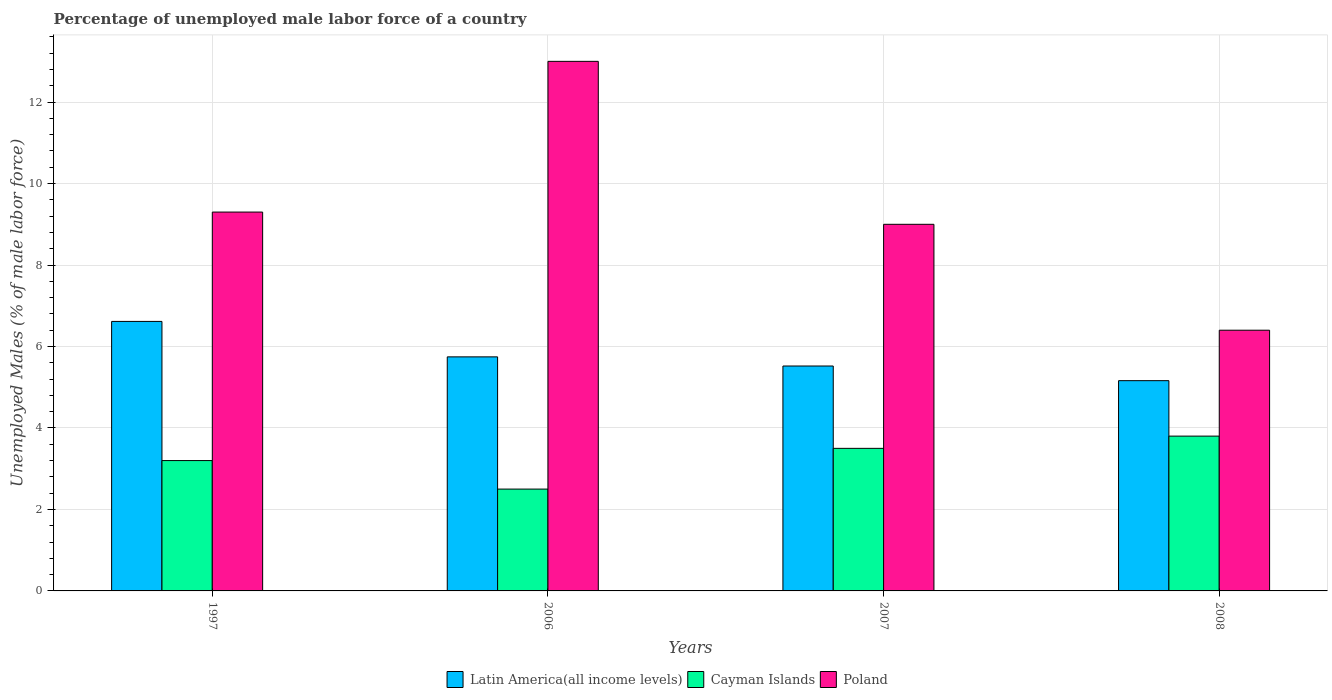How many groups of bars are there?
Your response must be concise. 4. Are the number of bars per tick equal to the number of legend labels?
Provide a short and direct response. Yes. What is the label of the 3rd group of bars from the left?
Your answer should be compact. 2007. What is the percentage of unemployed male labor force in Poland in 2007?
Make the answer very short. 9. Across all years, what is the maximum percentage of unemployed male labor force in Latin America(all income levels)?
Your response must be concise. 6.62. Across all years, what is the minimum percentage of unemployed male labor force in Latin America(all income levels)?
Your answer should be very brief. 5.16. What is the total percentage of unemployed male labor force in Latin America(all income levels) in the graph?
Provide a succinct answer. 23.04. What is the difference between the percentage of unemployed male labor force in Latin America(all income levels) in 2006 and that in 2007?
Keep it short and to the point. 0.22. What is the average percentage of unemployed male labor force in Latin America(all income levels) per year?
Give a very brief answer. 5.76. In the year 2006, what is the difference between the percentage of unemployed male labor force in Latin America(all income levels) and percentage of unemployed male labor force in Cayman Islands?
Keep it short and to the point. 3.25. In how many years, is the percentage of unemployed male labor force in Latin America(all income levels) greater than 2.4 %?
Make the answer very short. 4. What is the ratio of the percentage of unemployed male labor force in Poland in 2007 to that in 2008?
Make the answer very short. 1.41. What is the difference between the highest and the second highest percentage of unemployed male labor force in Latin America(all income levels)?
Ensure brevity in your answer.  0.87. What is the difference between the highest and the lowest percentage of unemployed male labor force in Poland?
Offer a very short reply. 6.6. What does the 3rd bar from the right in 1997 represents?
Your response must be concise. Latin America(all income levels). Is it the case that in every year, the sum of the percentage of unemployed male labor force in Poland and percentage of unemployed male labor force in Latin America(all income levels) is greater than the percentage of unemployed male labor force in Cayman Islands?
Ensure brevity in your answer.  Yes. Are all the bars in the graph horizontal?
Give a very brief answer. No. What is the difference between two consecutive major ticks on the Y-axis?
Your answer should be very brief. 2. Are the values on the major ticks of Y-axis written in scientific E-notation?
Your answer should be compact. No. Does the graph contain any zero values?
Your answer should be compact. No. How many legend labels are there?
Your answer should be compact. 3. What is the title of the graph?
Provide a short and direct response. Percentage of unemployed male labor force of a country. Does "Honduras" appear as one of the legend labels in the graph?
Provide a succinct answer. No. What is the label or title of the Y-axis?
Your answer should be compact. Unemployed Males (% of male labor force). What is the Unemployed Males (% of male labor force) in Latin America(all income levels) in 1997?
Keep it short and to the point. 6.62. What is the Unemployed Males (% of male labor force) of Cayman Islands in 1997?
Your answer should be very brief. 3.2. What is the Unemployed Males (% of male labor force) of Poland in 1997?
Your answer should be compact. 9.3. What is the Unemployed Males (% of male labor force) of Latin America(all income levels) in 2006?
Provide a succinct answer. 5.75. What is the Unemployed Males (% of male labor force) in Cayman Islands in 2006?
Keep it short and to the point. 2.5. What is the Unemployed Males (% of male labor force) in Latin America(all income levels) in 2007?
Provide a short and direct response. 5.52. What is the Unemployed Males (% of male labor force) in Cayman Islands in 2007?
Make the answer very short. 3.5. What is the Unemployed Males (% of male labor force) of Latin America(all income levels) in 2008?
Give a very brief answer. 5.16. What is the Unemployed Males (% of male labor force) of Cayman Islands in 2008?
Keep it short and to the point. 3.8. What is the Unemployed Males (% of male labor force) in Poland in 2008?
Provide a short and direct response. 6.4. Across all years, what is the maximum Unemployed Males (% of male labor force) in Latin America(all income levels)?
Your response must be concise. 6.62. Across all years, what is the maximum Unemployed Males (% of male labor force) of Cayman Islands?
Your answer should be compact. 3.8. Across all years, what is the maximum Unemployed Males (% of male labor force) of Poland?
Offer a very short reply. 13. Across all years, what is the minimum Unemployed Males (% of male labor force) in Latin America(all income levels)?
Ensure brevity in your answer.  5.16. Across all years, what is the minimum Unemployed Males (% of male labor force) in Poland?
Your answer should be compact. 6.4. What is the total Unemployed Males (% of male labor force) of Latin America(all income levels) in the graph?
Keep it short and to the point. 23.04. What is the total Unemployed Males (% of male labor force) of Cayman Islands in the graph?
Offer a very short reply. 13. What is the total Unemployed Males (% of male labor force) in Poland in the graph?
Offer a very short reply. 37.7. What is the difference between the Unemployed Males (% of male labor force) of Latin America(all income levels) in 1997 and that in 2006?
Offer a very short reply. 0.87. What is the difference between the Unemployed Males (% of male labor force) of Cayman Islands in 1997 and that in 2006?
Make the answer very short. 0.7. What is the difference between the Unemployed Males (% of male labor force) in Poland in 1997 and that in 2006?
Keep it short and to the point. -3.7. What is the difference between the Unemployed Males (% of male labor force) of Latin America(all income levels) in 1997 and that in 2007?
Your response must be concise. 1.09. What is the difference between the Unemployed Males (% of male labor force) of Latin America(all income levels) in 1997 and that in 2008?
Make the answer very short. 1.45. What is the difference between the Unemployed Males (% of male labor force) of Cayman Islands in 1997 and that in 2008?
Keep it short and to the point. -0.6. What is the difference between the Unemployed Males (% of male labor force) of Poland in 1997 and that in 2008?
Your response must be concise. 2.9. What is the difference between the Unemployed Males (% of male labor force) in Latin America(all income levels) in 2006 and that in 2007?
Ensure brevity in your answer.  0.22. What is the difference between the Unemployed Males (% of male labor force) in Cayman Islands in 2006 and that in 2007?
Provide a succinct answer. -1. What is the difference between the Unemployed Males (% of male labor force) in Poland in 2006 and that in 2007?
Offer a very short reply. 4. What is the difference between the Unemployed Males (% of male labor force) of Latin America(all income levels) in 2006 and that in 2008?
Ensure brevity in your answer.  0.58. What is the difference between the Unemployed Males (% of male labor force) of Latin America(all income levels) in 2007 and that in 2008?
Your answer should be very brief. 0.36. What is the difference between the Unemployed Males (% of male labor force) in Latin America(all income levels) in 1997 and the Unemployed Males (% of male labor force) in Cayman Islands in 2006?
Your answer should be compact. 4.12. What is the difference between the Unemployed Males (% of male labor force) of Latin America(all income levels) in 1997 and the Unemployed Males (% of male labor force) of Poland in 2006?
Provide a short and direct response. -6.38. What is the difference between the Unemployed Males (% of male labor force) in Cayman Islands in 1997 and the Unemployed Males (% of male labor force) in Poland in 2006?
Your answer should be compact. -9.8. What is the difference between the Unemployed Males (% of male labor force) in Latin America(all income levels) in 1997 and the Unemployed Males (% of male labor force) in Cayman Islands in 2007?
Your answer should be compact. 3.12. What is the difference between the Unemployed Males (% of male labor force) in Latin America(all income levels) in 1997 and the Unemployed Males (% of male labor force) in Poland in 2007?
Offer a very short reply. -2.38. What is the difference between the Unemployed Males (% of male labor force) of Cayman Islands in 1997 and the Unemployed Males (% of male labor force) of Poland in 2007?
Offer a terse response. -5.8. What is the difference between the Unemployed Males (% of male labor force) of Latin America(all income levels) in 1997 and the Unemployed Males (% of male labor force) of Cayman Islands in 2008?
Offer a very short reply. 2.82. What is the difference between the Unemployed Males (% of male labor force) in Latin America(all income levels) in 1997 and the Unemployed Males (% of male labor force) in Poland in 2008?
Give a very brief answer. 0.22. What is the difference between the Unemployed Males (% of male labor force) of Cayman Islands in 1997 and the Unemployed Males (% of male labor force) of Poland in 2008?
Your answer should be compact. -3.2. What is the difference between the Unemployed Males (% of male labor force) in Latin America(all income levels) in 2006 and the Unemployed Males (% of male labor force) in Cayman Islands in 2007?
Ensure brevity in your answer.  2.25. What is the difference between the Unemployed Males (% of male labor force) in Latin America(all income levels) in 2006 and the Unemployed Males (% of male labor force) in Poland in 2007?
Your answer should be very brief. -3.25. What is the difference between the Unemployed Males (% of male labor force) in Latin America(all income levels) in 2006 and the Unemployed Males (% of male labor force) in Cayman Islands in 2008?
Your response must be concise. 1.95. What is the difference between the Unemployed Males (% of male labor force) in Latin America(all income levels) in 2006 and the Unemployed Males (% of male labor force) in Poland in 2008?
Make the answer very short. -0.65. What is the difference between the Unemployed Males (% of male labor force) in Latin America(all income levels) in 2007 and the Unemployed Males (% of male labor force) in Cayman Islands in 2008?
Keep it short and to the point. 1.72. What is the difference between the Unemployed Males (% of male labor force) of Latin America(all income levels) in 2007 and the Unemployed Males (% of male labor force) of Poland in 2008?
Your answer should be compact. -0.88. What is the difference between the Unemployed Males (% of male labor force) of Cayman Islands in 2007 and the Unemployed Males (% of male labor force) of Poland in 2008?
Keep it short and to the point. -2.9. What is the average Unemployed Males (% of male labor force) of Latin America(all income levels) per year?
Give a very brief answer. 5.76. What is the average Unemployed Males (% of male labor force) in Cayman Islands per year?
Ensure brevity in your answer.  3.25. What is the average Unemployed Males (% of male labor force) in Poland per year?
Keep it short and to the point. 9.43. In the year 1997, what is the difference between the Unemployed Males (% of male labor force) of Latin America(all income levels) and Unemployed Males (% of male labor force) of Cayman Islands?
Ensure brevity in your answer.  3.42. In the year 1997, what is the difference between the Unemployed Males (% of male labor force) of Latin America(all income levels) and Unemployed Males (% of male labor force) of Poland?
Keep it short and to the point. -2.68. In the year 2006, what is the difference between the Unemployed Males (% of male labor force) in Latin America(all income levels) and Unemployed Males (% of male labor force) in Cayman Islands?
Provide a succinct answer. 3.25. In the year 2006, what is the difference between the Unemployed Males (% of male labor force) of Latin America(all income levels) and Unemployed Males (% of male labor force) of Poland?
Keep it short and to the point. -7.25. In the year 2006, what is the difference between the Unemployed Males (% of male labor force) in Cayman Islands and Unemployed Males (% of male labor force) in Poland?
Offer a very short reply. -10.5. In the year 2007, what is the difference between the Unemployed Males (% of male labor force) of Latin America(all income levels) and Unemployed Males (% of male labor force) of Cayman Islands?
Keep it short and to the point. 2.02. In the year 2007, what is the difference between the Unemployed Males (% of male labor force) of Latin America(all income levels) and Unemployed Males (% of male labor force) of Poland?
Provide a succinct answer. -3.48. In the year 2008, what is the difference between the Unemployed Males (% of male labor force) of Latin America(all income levels) and Unemployed Males (% of male labor force) of Cayman Islands?
Your answer should be very brief. 1.36. In the year 2008, what is the difference between the Unemployed Males (% of male labor force) of Latin America(all income levels) and Unemployed Males (% of male labor force) of Poland?
Give a very brief answer. -1.24. In the year 2008, what is the difference between the Unemployed Males (% of male labor force) of Cayman Islands and Unemployed Males (% of male labor force) of Poland?
Offer a very short reply. -2.6. What is the ratio of the Unemployed Males (% of male labor force) in Latin America(all income levels) in 1997 to that in 2006?
Make the answer very short. 1.15. What is the ratio of the Unemployed Males (% of male labor force) in Cayman Islands in 1997 to that in 2006?
Offer a very short reply. 1.28. What is the ratio of the Unemployed Males (% of male labor force) in Poland in 1997 to that in 2006?
Your response must be concise. 0.72. What is the ratio of the Unemployed Males (% of male labor force) in Latin America(all income levels) in 1997 to that in 2007?
Your response must be concise. 1.2. What is the ratio of the Unemployed Males (% of male labor force) in Cayman Islands in 1997 to that in 2007?
Give a very brief answer. 0.91. What is the ratio of the Unemployed Males (% of male labor force) of Poland in 1997 to that in 2007?
Make the answer very short. 1.03. What is the ratio of the Unemployed Males (% of male labor force) of Latin America(all income levels) in 1997 to that in 2008?
Provide a short and direct response. 1.28. What is the ratio of the Unemployed Males (% of male labor force) of Cayman Islands in 1997 to that in 2008?
Provide a short and direct response. 0.84. What is the ratio of the Unemployed Males (% of male labor force) of Poland in 1997 to that in 2008?
Your response must be concise. 1.45. What is the ratio of the Unemployed Males (% of male labor force) in Latin America(all income levels) in 2006 to that in 2007?
Your answer should be very brief. 1.04. What is the ratio of the Unemployed Males (% of male labor force) of Poland in 2006 to that in 2007?
Keep it short and to the point. 1.44. What is the ratio of the Unemployed Males (% of male labor force) in Latin America(all income levels) in 2006 to that in 2008?
Offer a terse response. 1.11. What is the ratio of the Unemployed Males (% of male labor force) in Cayman Islands in 2006 to that in 2008?
Ensure brevity in your answer.  0.66. What is the ratio of the Unemployed Males (% of male labor force) in Poland in 2006 to that in 2008?
Provide a short and direct response. 2.03. What is the ratio of the Unemployed Males (% of male labor force) of Latin America(all income levels) in 2007 to that in 2008?
Ensure brevity in your answer.  1.07. What is the ratio of the Unemployed Males (% of male labor force) in Cayman Islands in 2007 to that in 2008?
Keep it short and to the point. 0.92. What is the ratio of the Unemployed Males (% of male labor force) in Poland in 2007 to that in 2008?
Ensure brevity in your answer.  1.41. What is the difference between the highest and the second highest Unemployed Males (% of male labor force) of Latin America(all income levels)?
Your answer should be very brief. 0.87. What is the difference between the highest and the second highest Unemployed Males (% of male labor force) of Cayman Islands?
Provide a succinct answer. 0.3. What is the difference between the highest and the lowest Unemployed Males (% of male labor force) of Latin America(all income levels)?
Make the answer very short. 1.45. What is the difference between the highest and the lowest Unemployed Males (% of male labor force) of Cayman Islands?
Provide a succinct answer. 1.3. 